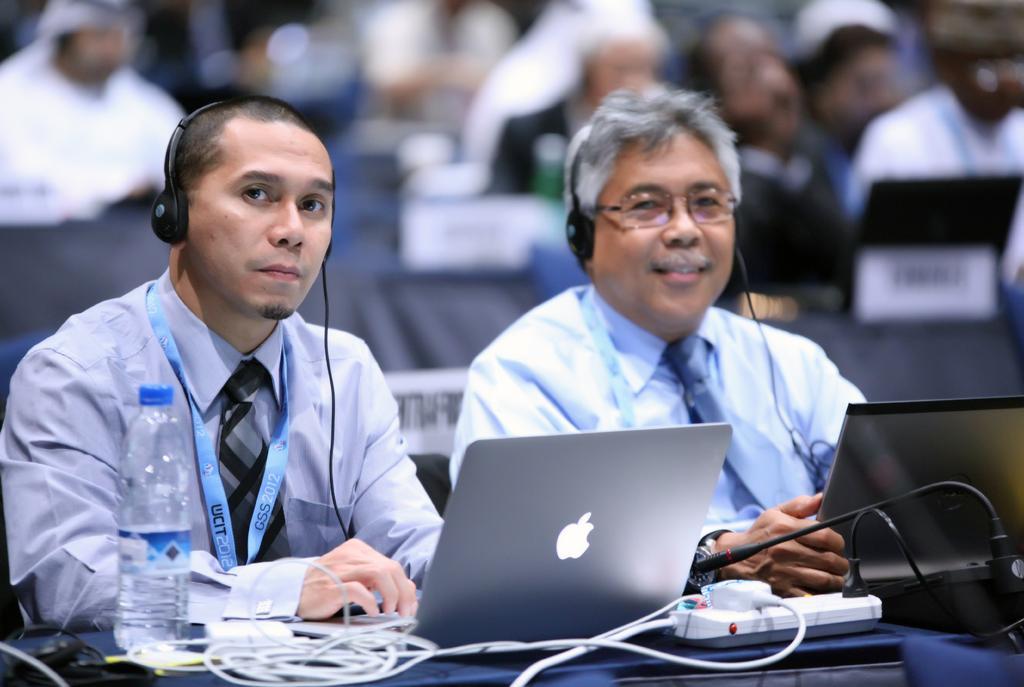Can you describe this image briefly? In this picture we can see there are two men with the headsets. In front of the people there are laptops, cables, a bottle and an extension socket. Behind the men, there are blurred people. 